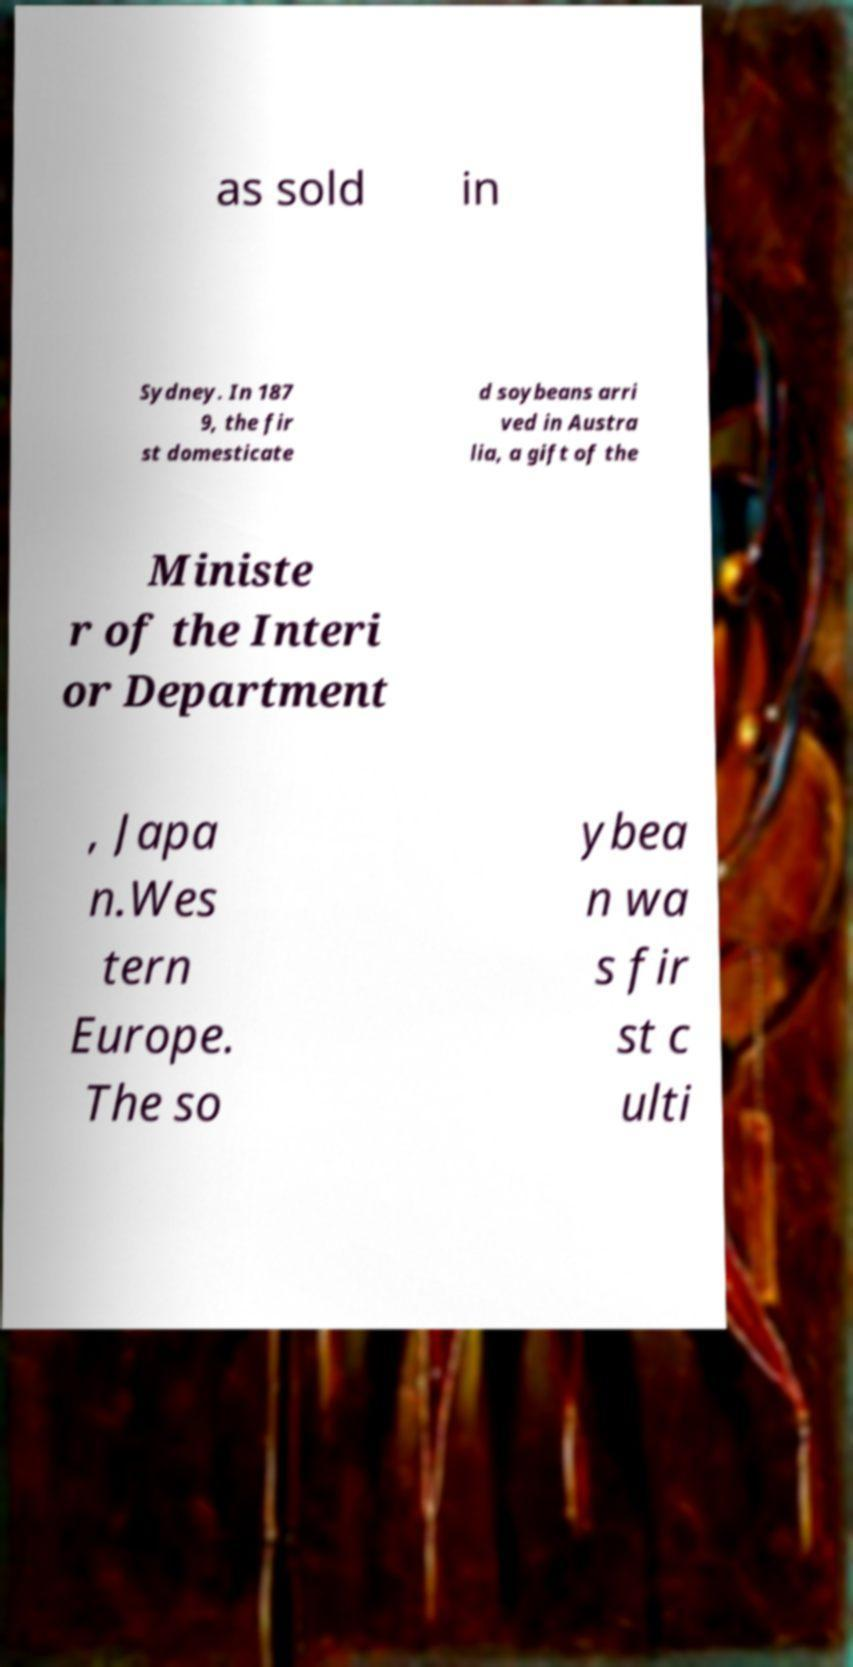What messages or text are displayed in this image? I need them in a readable, typed format. as sold in Sydney. In 187 9, the fir st domesticate d soybeans arri ved in Austra lia, a gift of the Ministe r of the Interi or Department , Japa n.Wes tern Europe. The so ybea n wa s fir st c ulti 